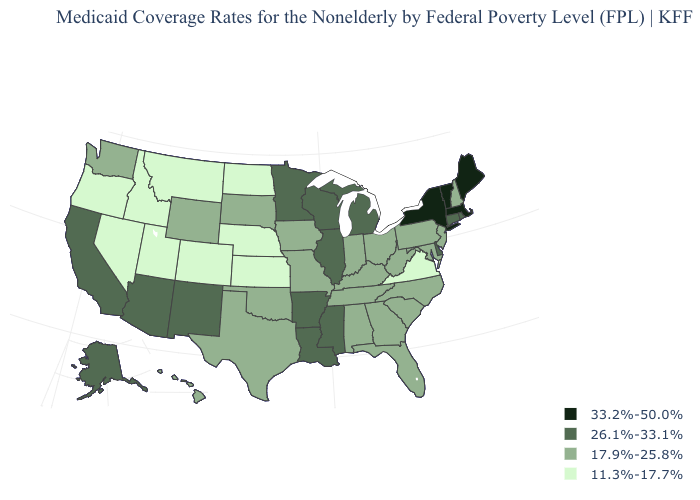Name the states that have a value in the range 17.9%-25.8%?
Short answer required. Alabama, Florida, Georgia, Hawaii, Indiana, Iowa, Kentucky, Maryland, Missouri, New Hampshire, New Jersey, North Carolina, Ohio, Oklahoma, Pennsylvania, South Carolina, South Dakota, Tennessee, Texas, Washington, West Virginia, Wyoming. Name the states that have a value in the range 33.2%-50.0%?
Quick response, please. Maine, Massachusetts, New York, Vermont. Name the states that have a value in the range 26.1%-33.1%?
Answer briefly. Alaska, Arizona, Arkansas, California, Connecticut, Delaware, Illinois, Louisiana, Michigan, Minnesota, Mississippi, New Mexico, Rhode Island, Wisconsin. Name the states that have a value in the range 11.3%-17.7%?
Keep it brief. Colorado, Idaho, Kansas, Montana, Nebraska, Nevada, North Dakota, Oregon, Utah, Virginia. What is the lowest value in the USA?
Answer briefly. 11.3%-17.7%. Name the states that have a value in the range 17.9%-25.8%?
Answer briefly. Alabama, Florida, Georgia, Hawaii, Indiana, Iowa, Kentucky, Maryland, Missouri, New Hampshire, New Jersey, North Carolina, Ohio, Oklahoma, Pennsylvania, South Carolina, South Dakota, Tennessee, Texas, Washington, West Virginia, Wyoming. What is the value of South Carolina?
Write a very short answer. 17.9%-25.8%. What is the value of Connecticut?
Quick response, please. 26.1%-33.1%. Name the states that have a value in the range 33.2%-50.0%?
Answer briefly. Maine, Massachusetts, New York, Vermont. Does Illinois have the highest value in the MidWest?
Give a very brief answer. Yes. Name the states that have a value in the range 17.9%-25.8%?
Answer briefly. Alabama, Florida, Georgia, Hawaii, Indiana, Iowa, Kentucky, Maryland, Missouri, New Hampshire, New Jersey, North Carolina, Ohio, Oklahoma, Pennsylvania, South Carolina, South Dakota, Tennessee, Texas, Washington, West Virginia, Wyoming. Does Colorado have the same value as Nebraska?
Give a very brief answer. Yes. What is the value of Alabama?
Keep it brief. 17.9%-25.8%. Does North Carolina have a higher value than Idaho?
Write a very short answer. Yes. 